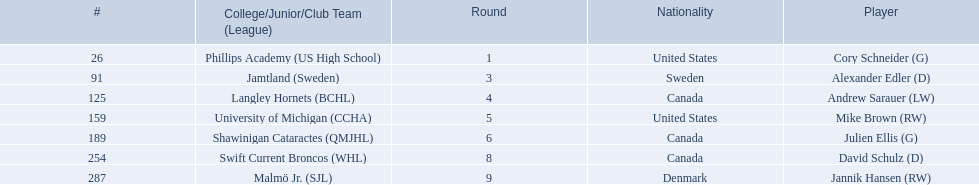What are the names of the colleges and jr leagues the players attended? Phillips Academy (US High School), Jamtland (Sweden), Langley Hornets (BCHL), University of Michigan (CCHA), Shawinigan Cataractes (QMJHL), Swift Current Broncos (WHL), Malmö Jr. (SJL). Which player played for the langley hornets? Andrew Sarauer (LW). 